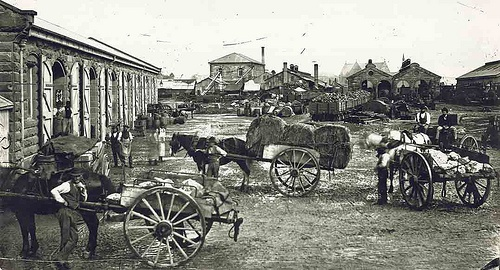Describe the objects in this image and their specific colors. I can see horse in black and gray tones, people in black, gray, and white tones, horse in black, gray, and darkgray tones, horse in black, gray, ivory, and darkgray tones, and people in black, gray, ivory, and darkgray tones in this image. 